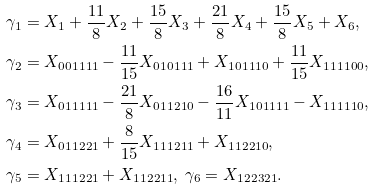<formula> <loc_0><loc_0><loc_500><loc_500>& \gamma _ { 1 } = X _ { 1 } + \frac { 1 1 } { 8 } X _ { 2 } + \frac { 1 5 } { 8 } X _ { 3 } + \frac { 2 1 } { 8 } X _ { 4 } + \frac { 1 5 } { 8 } X _ { 5 } + X _ { 6 } , \\ & \gamma _ { 2 } = X _ { 0 0 1 1 1 1 } - \frac { 1 1 } { 1 5 } X _ { 0 1 0 1 1 1 } + X _ { 1 0 1 1 1 0 } + \frac { 1 1 } { 1 5 } X _ { 1 1 1 1 0 0 } , \\ & \gamma _ { 3 } = X _ { 0 1 1 1 1 1 } - \frac { 2 1 } { 8 } X _ { 0 1 1 2 1 0 } - \frac { 1 6 } { 1 1 } X _ { 1 0 1 1 1 1 } - X _ { 1 1 1 1 1 0 } , \\ & \gamma _ { 4 } = X _ { 0 1 1 2 2 1 } + \frac { 8 } { 1 5 } X _ { 1 1 1 2 1 1 } + X _ { 1 1 2 2 1 0 } , \\ & \gamma _ { 5 } = X _ { 1 1 1 2 2 1 } + X _ { 1 1 2 2 1 1 } , \ \gamma _ { 6 } = X _ { 1 2 2 3 2 1 } .</formula> 